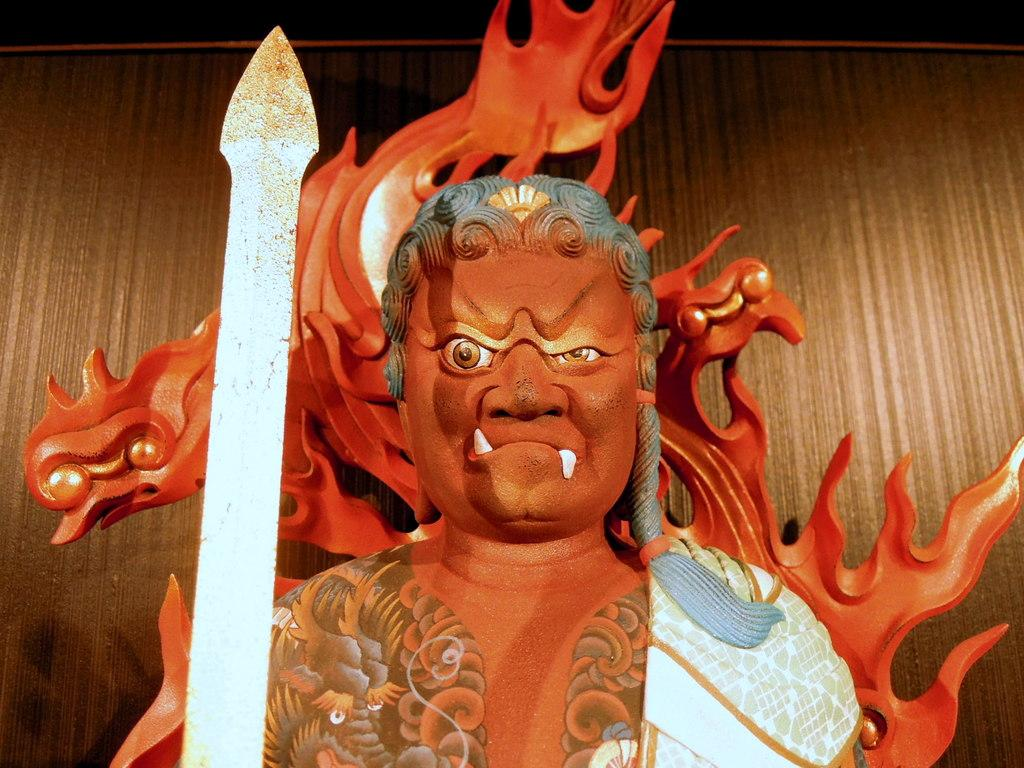What is the main subject of the image? There is a sculpture in the image. Can you describe the background of the image? There is a wooden wall in the background of the image. How many toes are visible on the sculpture in the image? There are no toes visible on the sculpture in the image, as it is a sculpture and not a living being. 